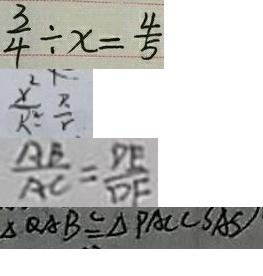<formula> <loc_0><loc_0><loc_500><loc_500>\frac { 3 } { 4 } \div x = \frac { 4 } { 5 } 
 \frac { x ^ { 2 } } { R ^ { 2 } } = \frac { R } { r } 
 \frac { A B } { A C } = \frac { D E } { D F } 
 \Delta Q A B \cong \Delta P A C ( S A S )</formula> 